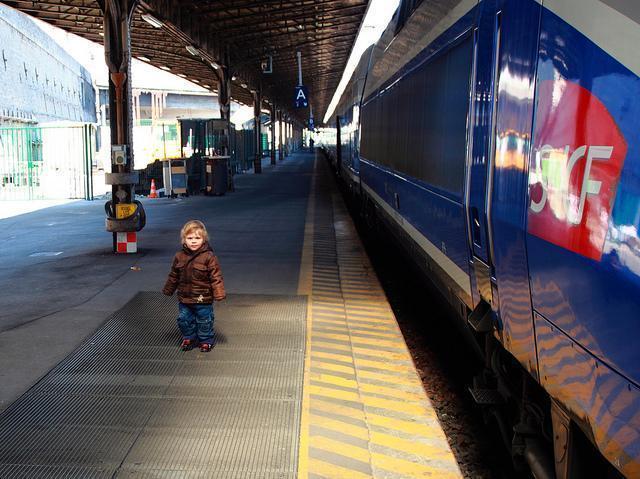What is this child's parent doing?
Select the accurate answer and provide justification: `Answer: choice
Rationale: srationale.`
Options: Taking photograph, working, escaping, abandoning it. Answer: taking photograph.
Rationale: The parent is taking the photo. 